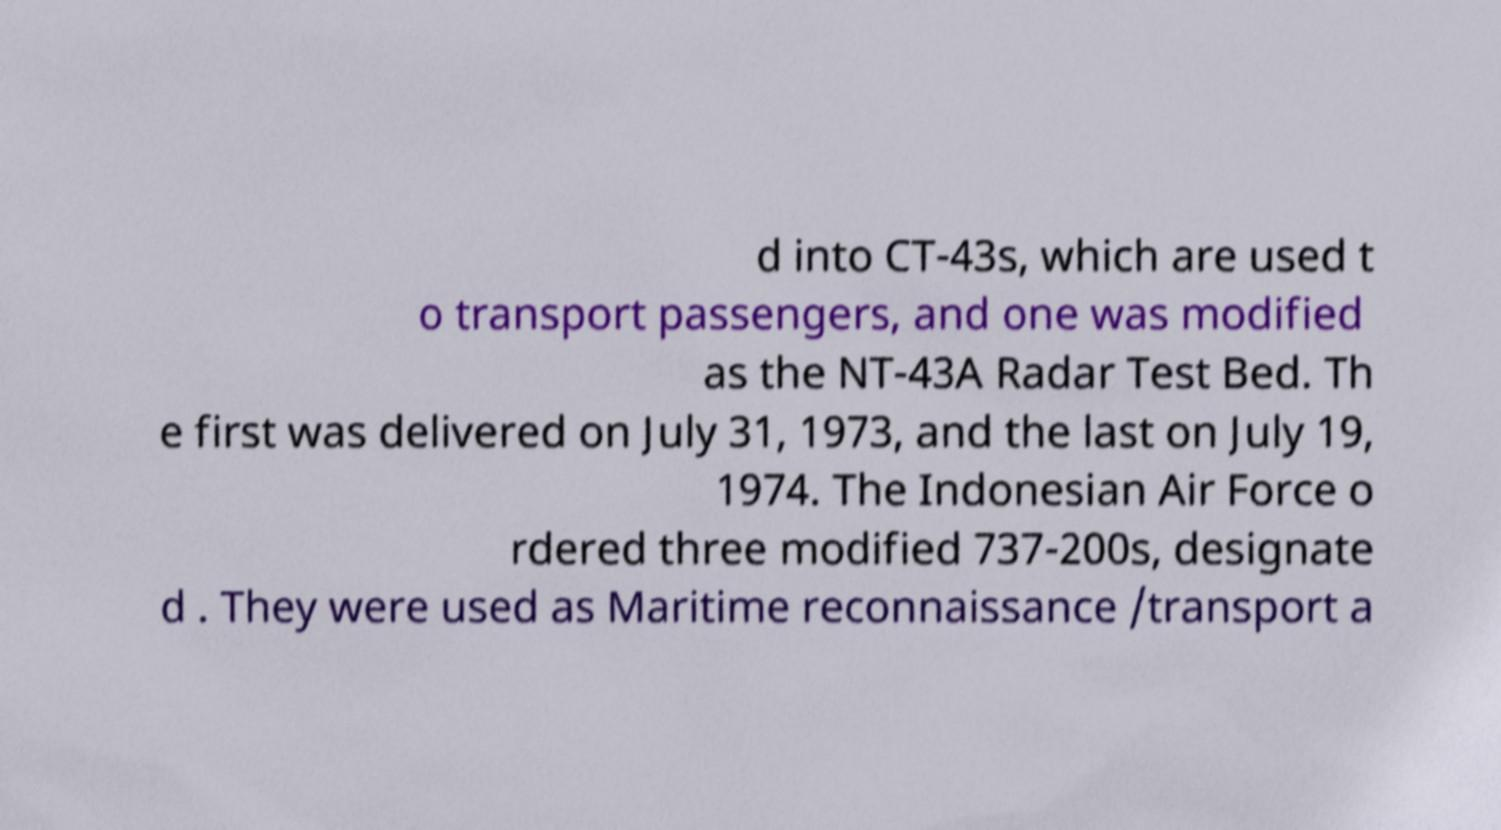I need the written content from this picture converted into text. Can you do that? d into CT-43s, which are used t o transport passengers, and one was modified as the NT-43A Radar Test Bed. Th e first was delivered on July 31, 1973, and the last on July 19, 1974. The Indonesian Air Force o rdered three modified 737-200s, designate d . They were used as Maritime reconnaissance /transport a 